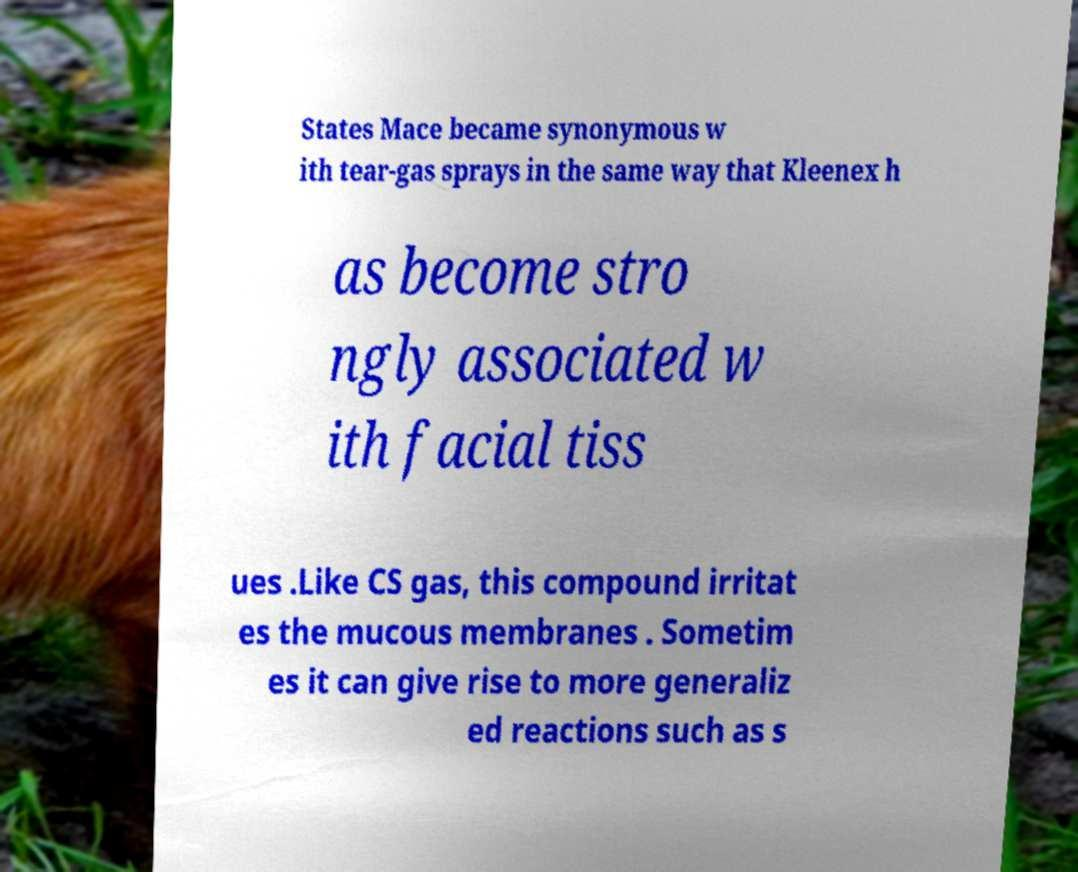Please read and relay the text visible in this image. What does it say? States Mace became synonymous w ith tear-gas sprays in the same way that Kleenex h as become stro ngly associated w ith facial tiss ues .Like CS gas, this compound irritat es the mucous membranes . Sometim es it can give rise to more generaliz ed reactions such as s 